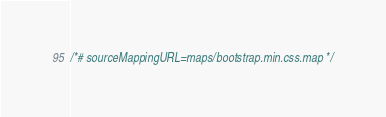<code> <loc_0><loc_0><loc_500><loc_500><_CSS_>/*# sourceMappingURL=maps/bootstrap.min.css.map */</code> 